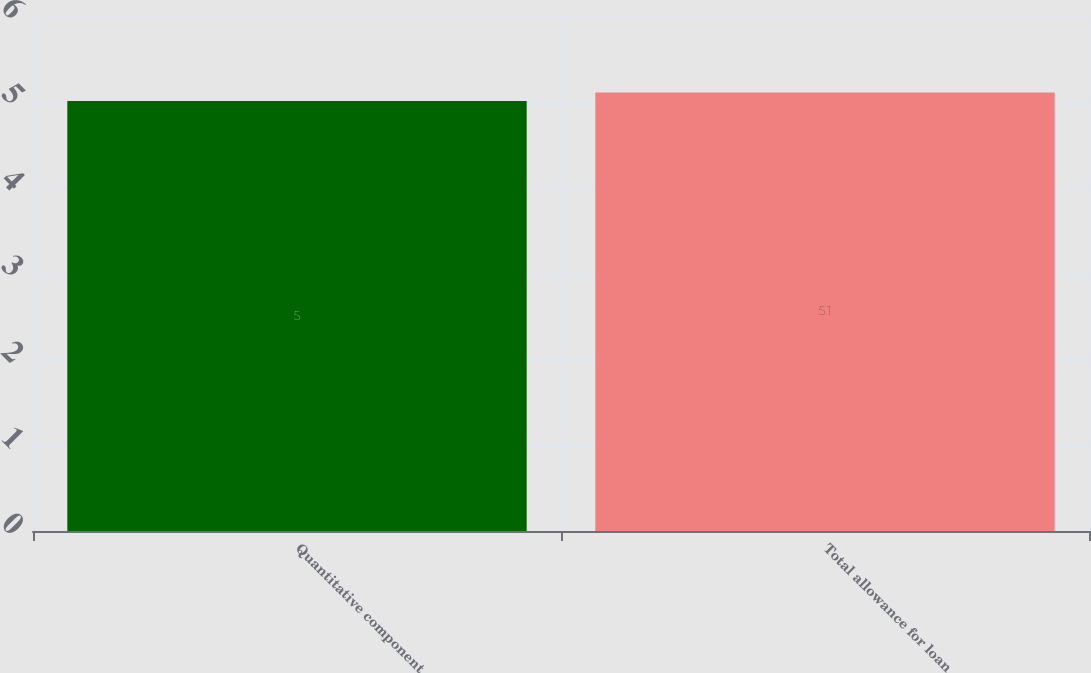<chart> <loc_0><loc_0><loc_500><loc_500><bar_chart><fcel>Quantitative component<fcel>Total allowance for loan<nl><fcel>5<fcel>5.1<nl></chart> 